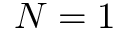<formula> <loc_0><loc_0><loc_500><loc_500>N = 1</formula> 